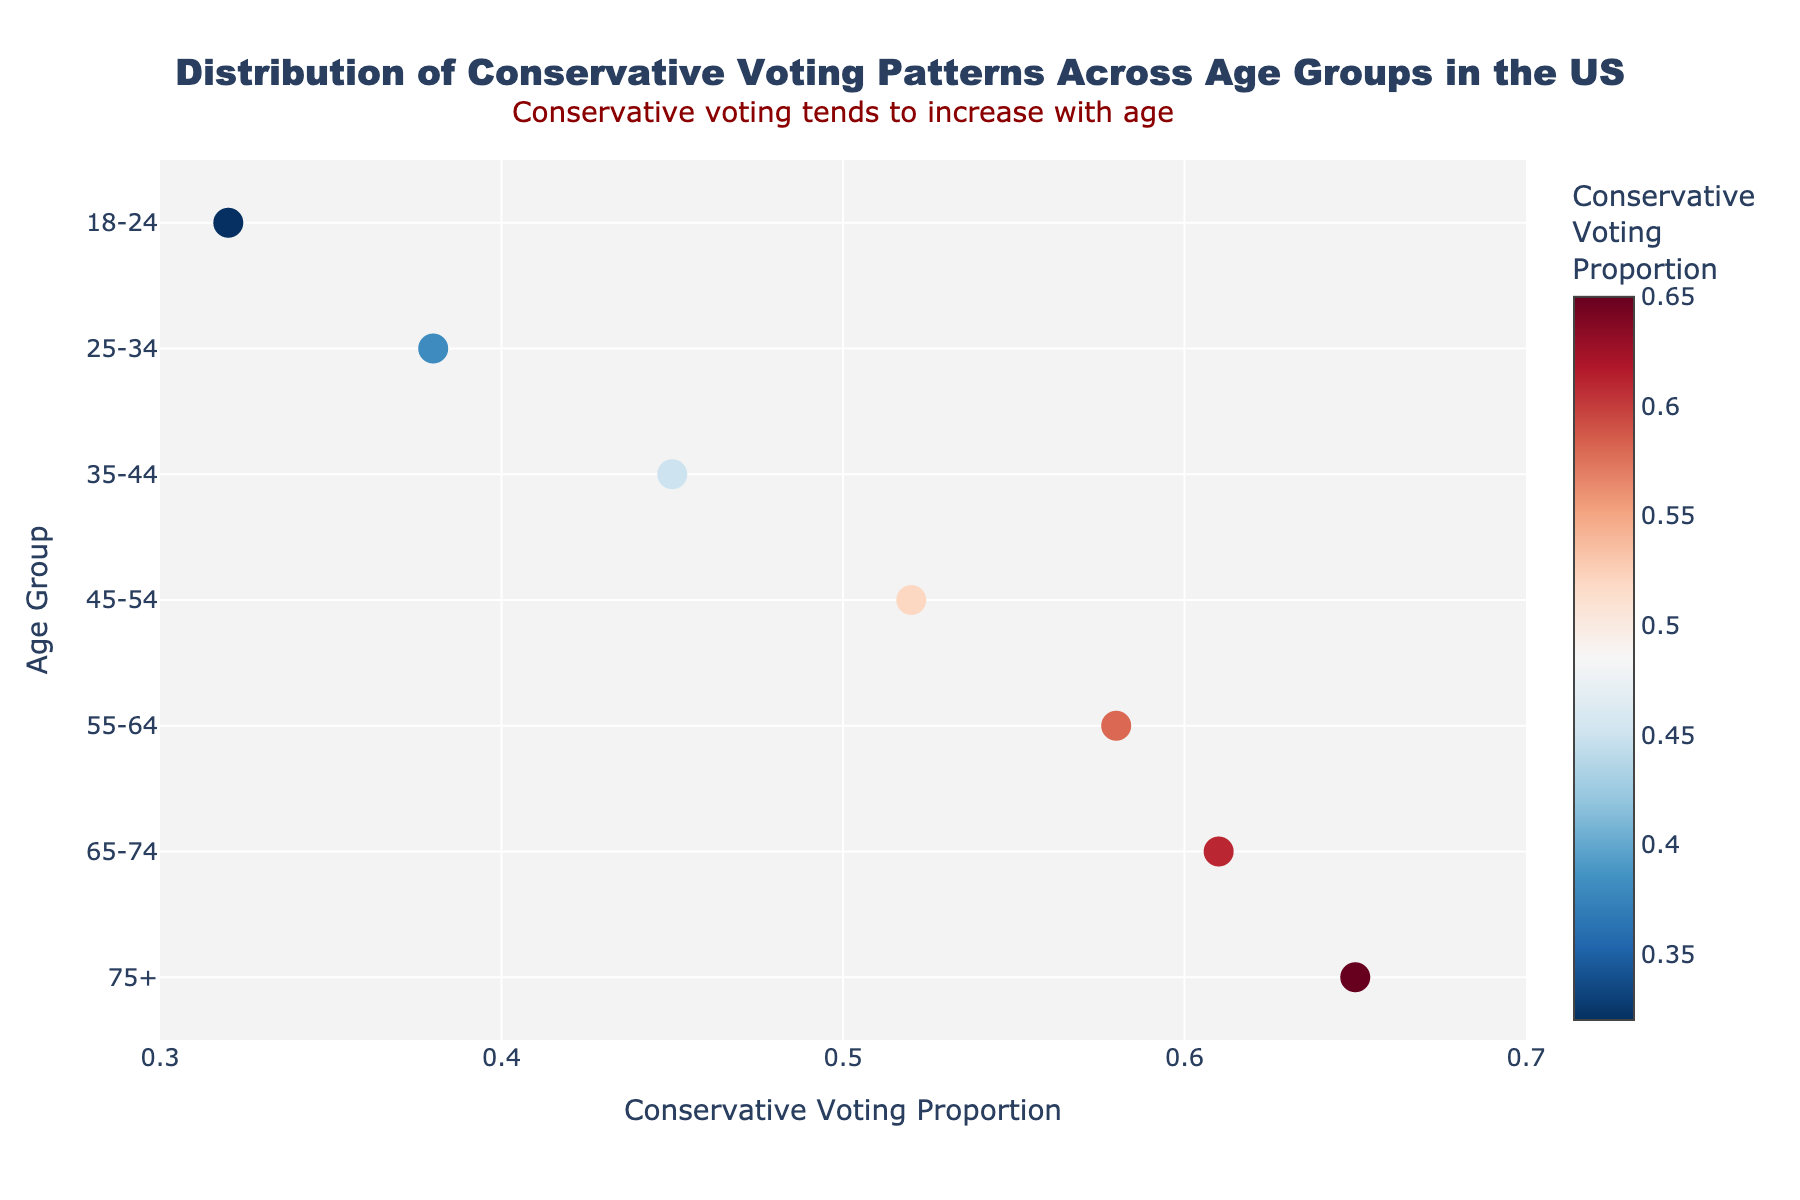What is the title of the figure? The title of the figure is typically found at the top of the plot and gives a clear description of what the figure represents. In this case, it reads "Distribution of Conservative Voting Patterns Across Age Groups in the US."
Answer: Distribution of Conservative Voting Patterns Across Age Groups in the US What does the x-axis represent? The x-axis usually signifies the variable being measured. Here, it represents the "Conservative Voting Proportion," which is the proportion of conservative votes across different age groups.
Answer: Conservative Voting Proportion Which age group has the highest conservative voting proportion? To determine the highest value, look at the age group with the highest marker position on the x-axis. The age group "75+" has the furthest right marker, denoting the highest proportion.
Answer: 75+ How does the conservative voting proportion change with age? Observing the trend of the markers from the youngest age group to the oldest, they move from lower x-axis values to higher x-axis values. This indicates an increasing trend in conservative voting proportion with age.
Answer: Increases with age What is the conservative voting proportion for the 25-34 age group? Locate the marker corresponding to the "25-34" age group along the x-axis. The value displayed for this age group is approximately 0.38.
Answer: 0.38 Which age group shows a conservative voting proportion closest to 0.5? Identify the marker closest to 0.5 on the x-axis. The "45-54" age group has a conservative voting proportion very close to 0.5, specifically 0.52.
Answer: 45-54 What is the range of conservative voting proportions across all age groups? Find the minimum and maximum x-axis values for the markers. The minimum is 0.32 (for 18-24), and the maximum is 0.65 (for 75+), so the range is 0.65 - 0.32 = 0.33.
Answer: 0.33 Which age group has the least conservative voting proportion, and what is the value? Locate the age group with the marker at the smallest x-axis position. The "18-24" age group has the least conservative voting proportion, which is 0.32.
Answer: 18-24, 0.32 How much does the conservative voting proportion increase from the 18-24 group to the 75+ group? Subtract the conservative voting proportion of the "18-24" group from the "75+" group. The difference is 0.65 - 0.32 = 0.33.
Answer: 0.33 Is there any annotation on the figure? What does it say? Annotations are often textual elements highlighting key observations. The annotation in this figure reads, "Conservative voting tends to increase with age," placed above the title.
Answer: Conservative voting tends to increase with age 